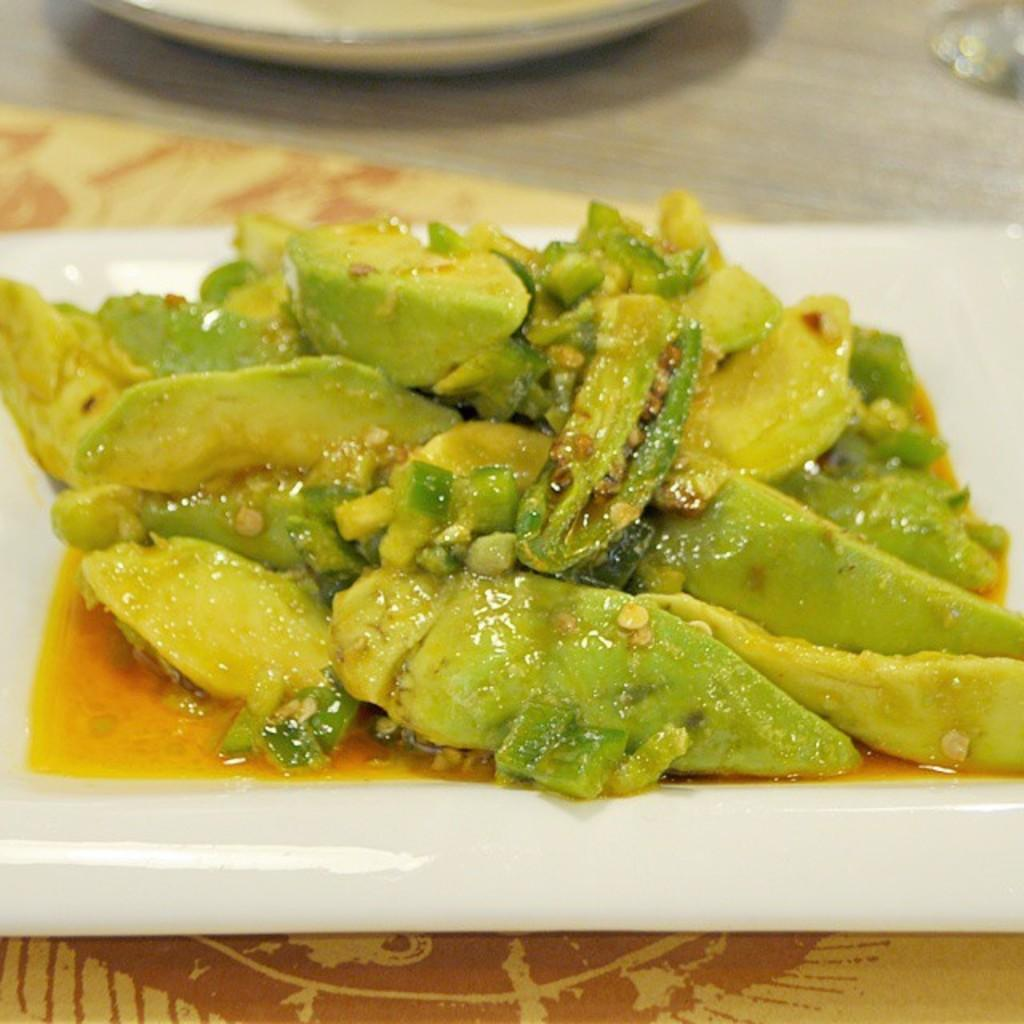What is on the plate that is visible in the image? There is a plate with food items in the image. What color is the plate? The plate is white in color. Where is the plate located in the image? The plate is on a table. What type of thrill can be seen on the plate in the image? There is no thrill present on the plate in the image; it is a plate with food items. What type of fork is used to eat the food on the plate in the image? There is no fork visible in the image, so it cannot be determined what type of fork might be used. 